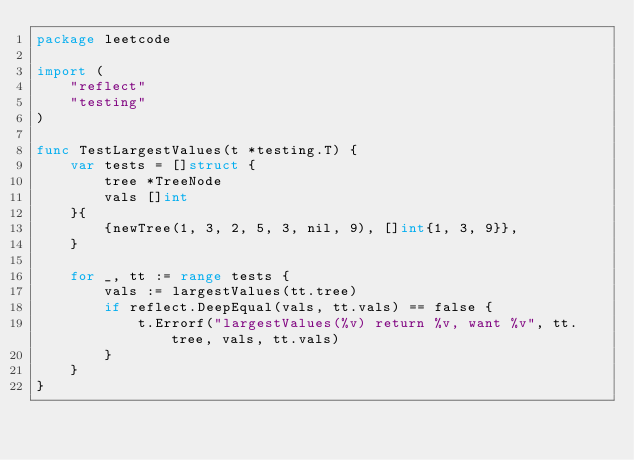Convert code to text. <code><loc_0><loc_0><loc_500><loc_500><_Go_>package leetcode

import (
	"reflect"
	"testing"
)

func TestLargestValues(t *testing.T) {
	var tests = []struct {
		tree *TreeNode
		vals []int
	}{
		{newTree(1, 3, 2, 5, 3, nil, 9), []int{1, 3, 9}},
	}

	for _, tt := range tests {
		vals := largestValues(tt.tree)
		if reflect.DeepEqual(vals, tt.vals) == false {
			t.Errorf("largestValues(%v) return %v, want %v", tt.tree, vals, tt.vals)
		}
	}
}
</code> 